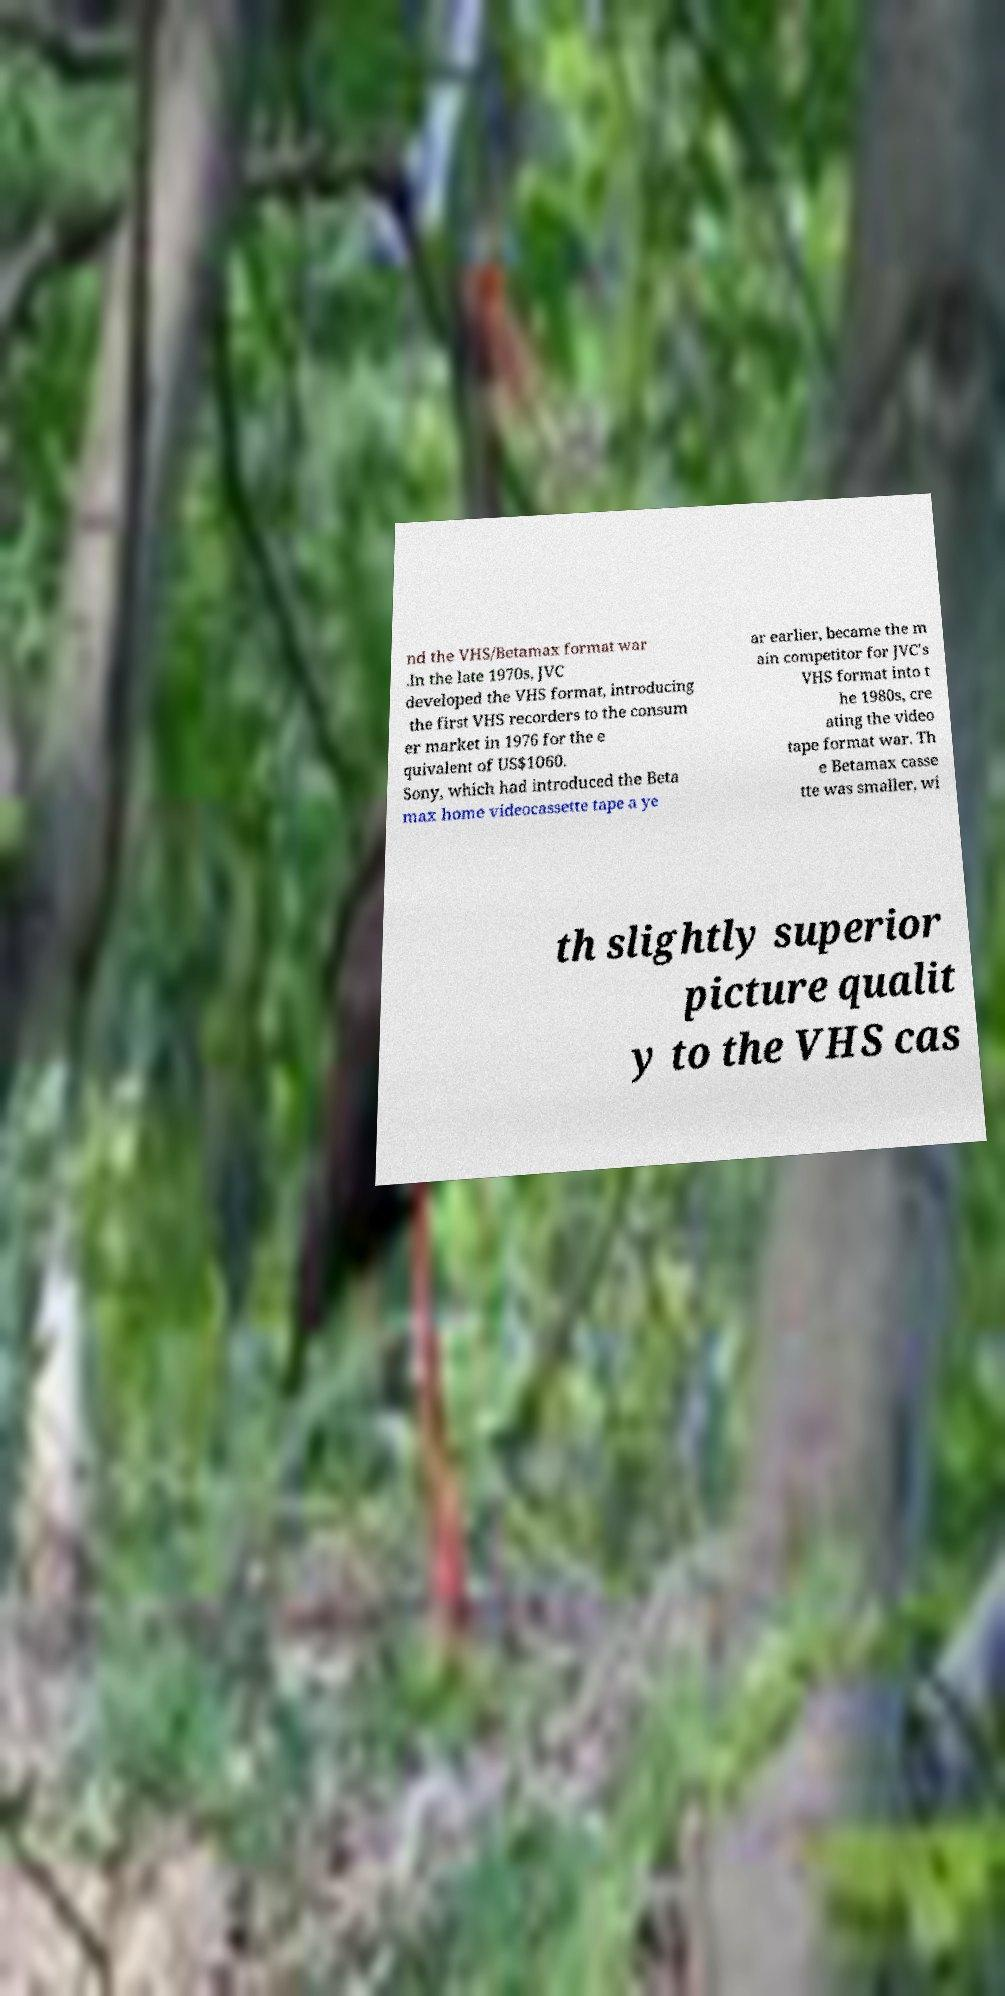What messages or text are displayed in this image? I need them in a readable, typed format. nd the VHS/Betamax format war .In the late 1970s, JVC developed the VHS format, introducing the first VHS recorders to the consum er market in 1976 for the e quivalent of US$1060. Sony, which had introduced the Beta max home videocassette tape a ye ar earlier, became the m ain competitor for JVC's VHS format into t he 1980s, cre ating the video tape format war. Th e Betamax casse tte was smaller, wi th slightly superior picture qualit y to the VHS cas 